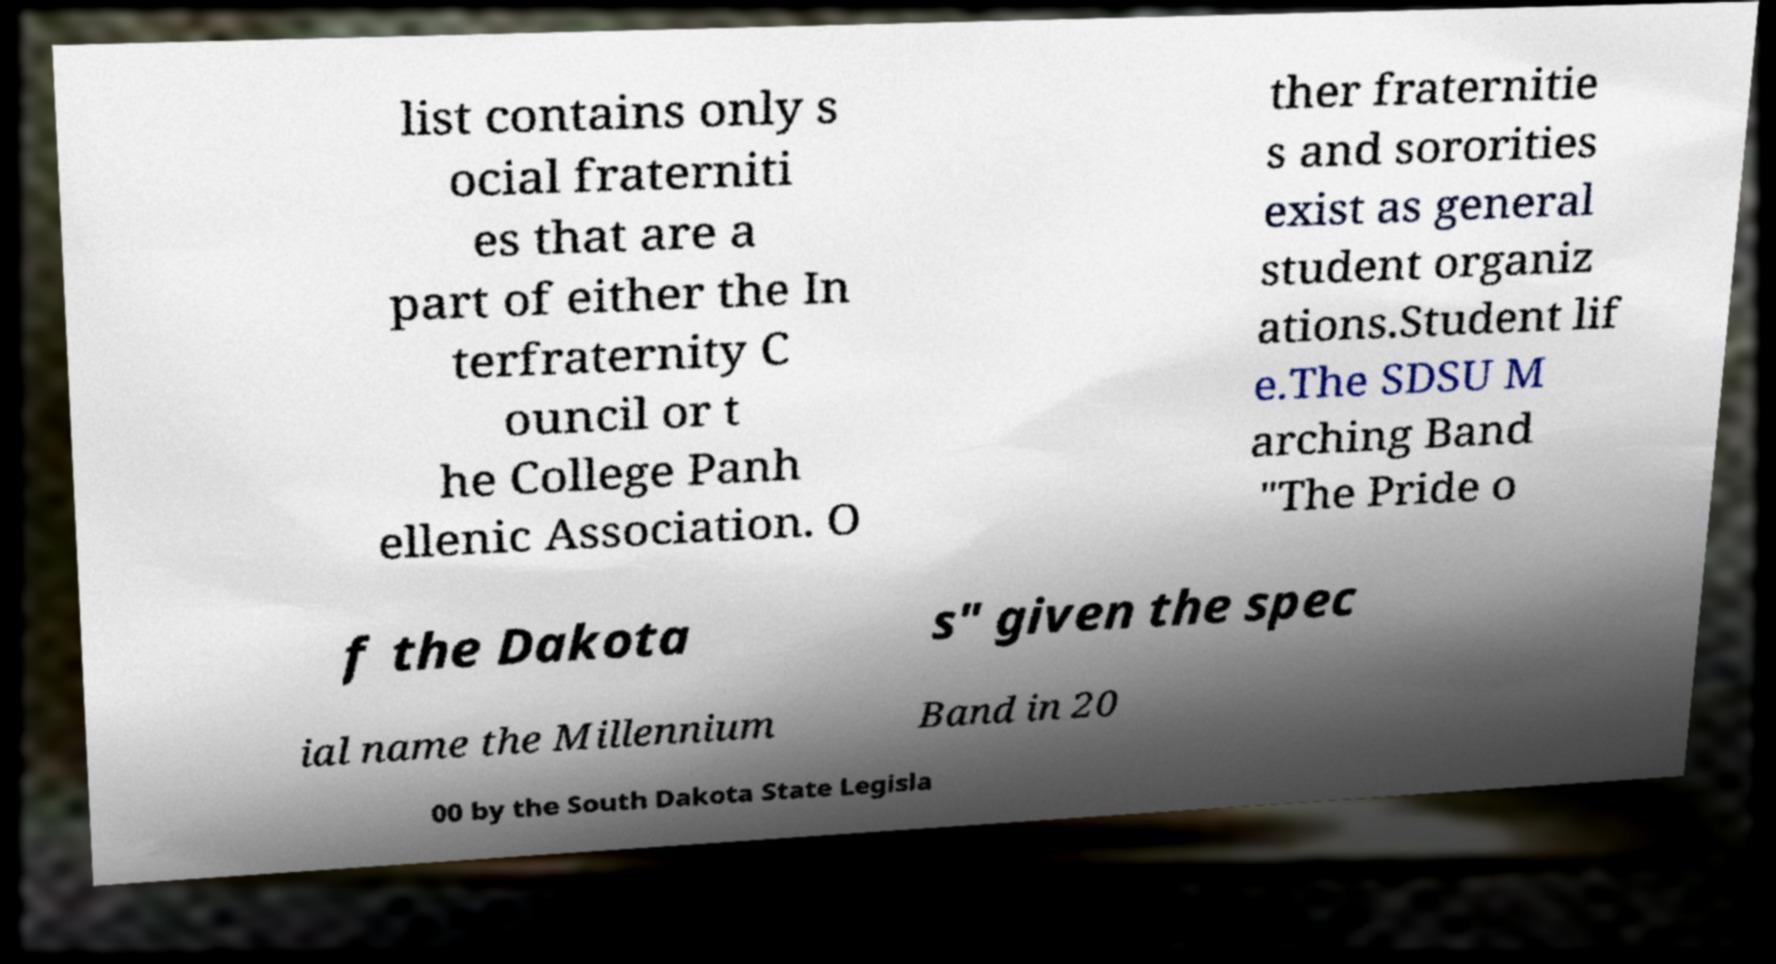There's text embedded in this image that I need extracted. Can you transcribe it verbatim? list contains only s ocial fraterniti es that are a part of either the In terfraternity C ouncil or t he College Panh ellenic Association. O ther fraternitie s and sororities exist as general student organiz ations.Student lif e.The SDSU M arching Band "The Pride o f the Dakota s" given the spec ial name the Millennium Band in 20 00 by the South Dakota State Legisla 